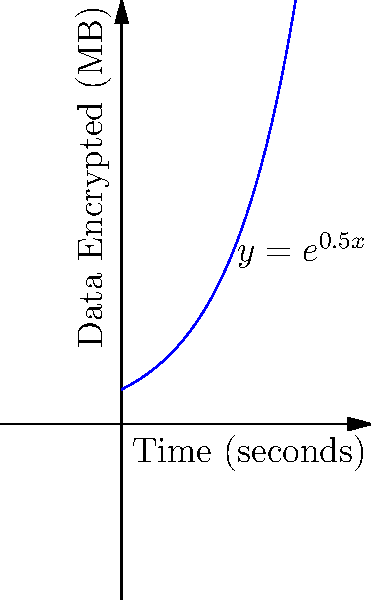A rival hacker's encryption algorithm follows the function $y = e^{0.5x}$, where $y$ represents the amount of data encrypted in megabytes and $x$ represents time in seconds. At what rate is data being encrypted after 3 seconds? To find the rate of data encryption at 3 seconds, we need to calculate the derivative of the function at x = 3.

1) The given function is $y = e^{0.5x}$

2) The derivative of $e^x$ is $e^x$, and using the chain rule, we get:
   $\frac{dy}{dx} = 0.5e^{0.5x}$

3) To find the rate at 3 seconds, substitute x = 3:
   $\frac{dy}{dx}|_{x=3} = 0.5e^{0.5(3)} = 0.5e^{1.5}$

4) Calculate the value:
   $0.5e^{1.5} \approx 2.24$ MB/second

This means that after 3 seconds, data is being encrypted at a rate of approximately 2.24 megabytes per second.
Answer: $0.5e^{1.5}$ MB/s 